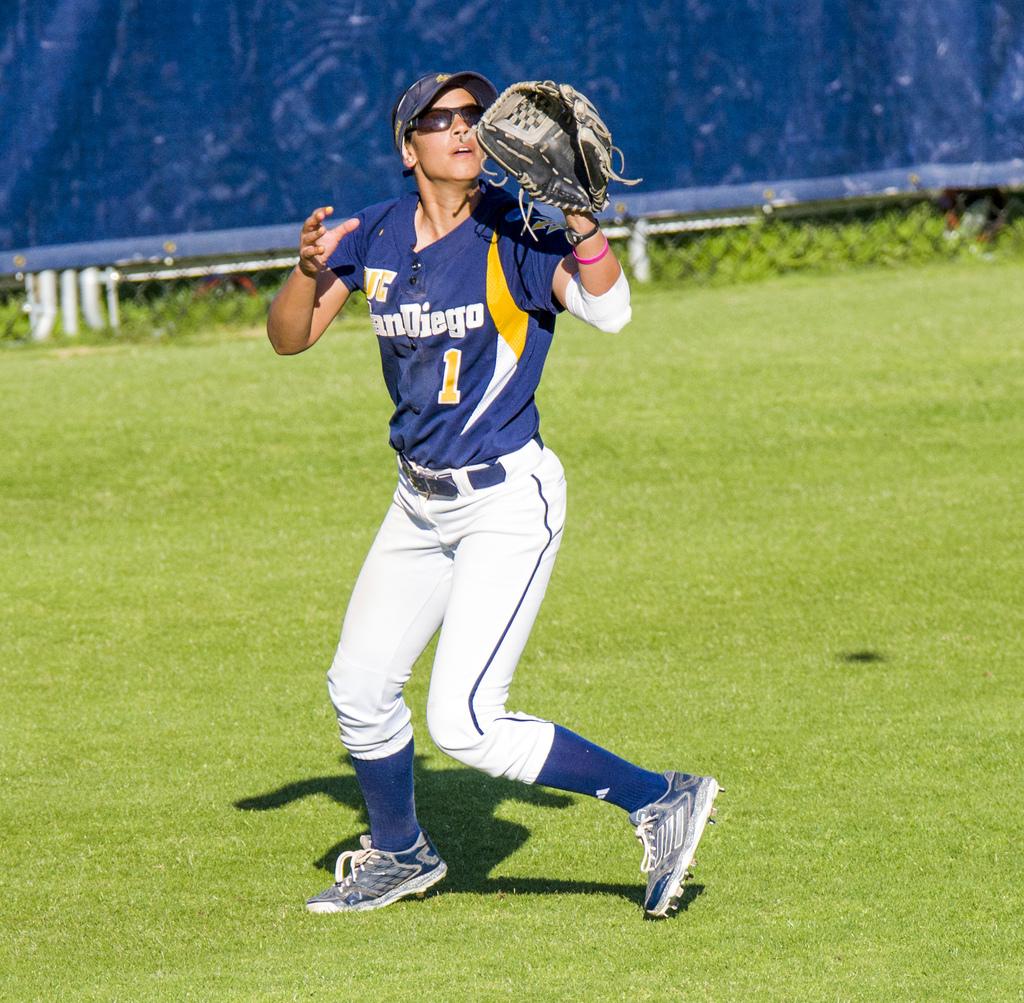What is her number?
Offer a very short reply. 1. What team does this player play for?
Provide a succinct answer. San diego. 